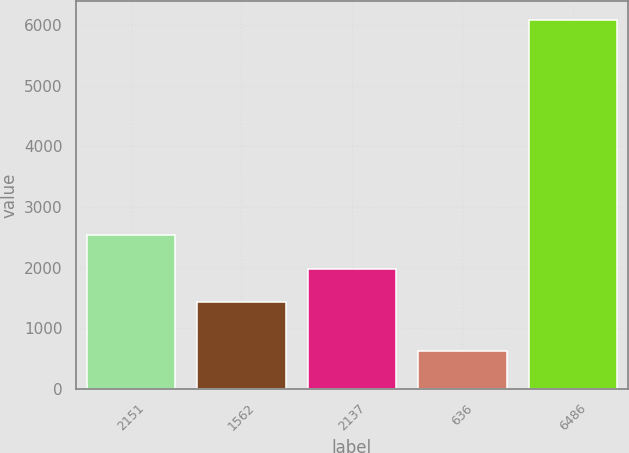<chart> <loc_0><loc_0><loc_500><loc_500><bar_chart><fcel>2151<fcel>1562<fcel>2137<fcel>636<fcel>6486<nl><fcel>2530.6<fcel>1438<fcel>1984.3<fcel>624<fcel>6087<nl></chart> 